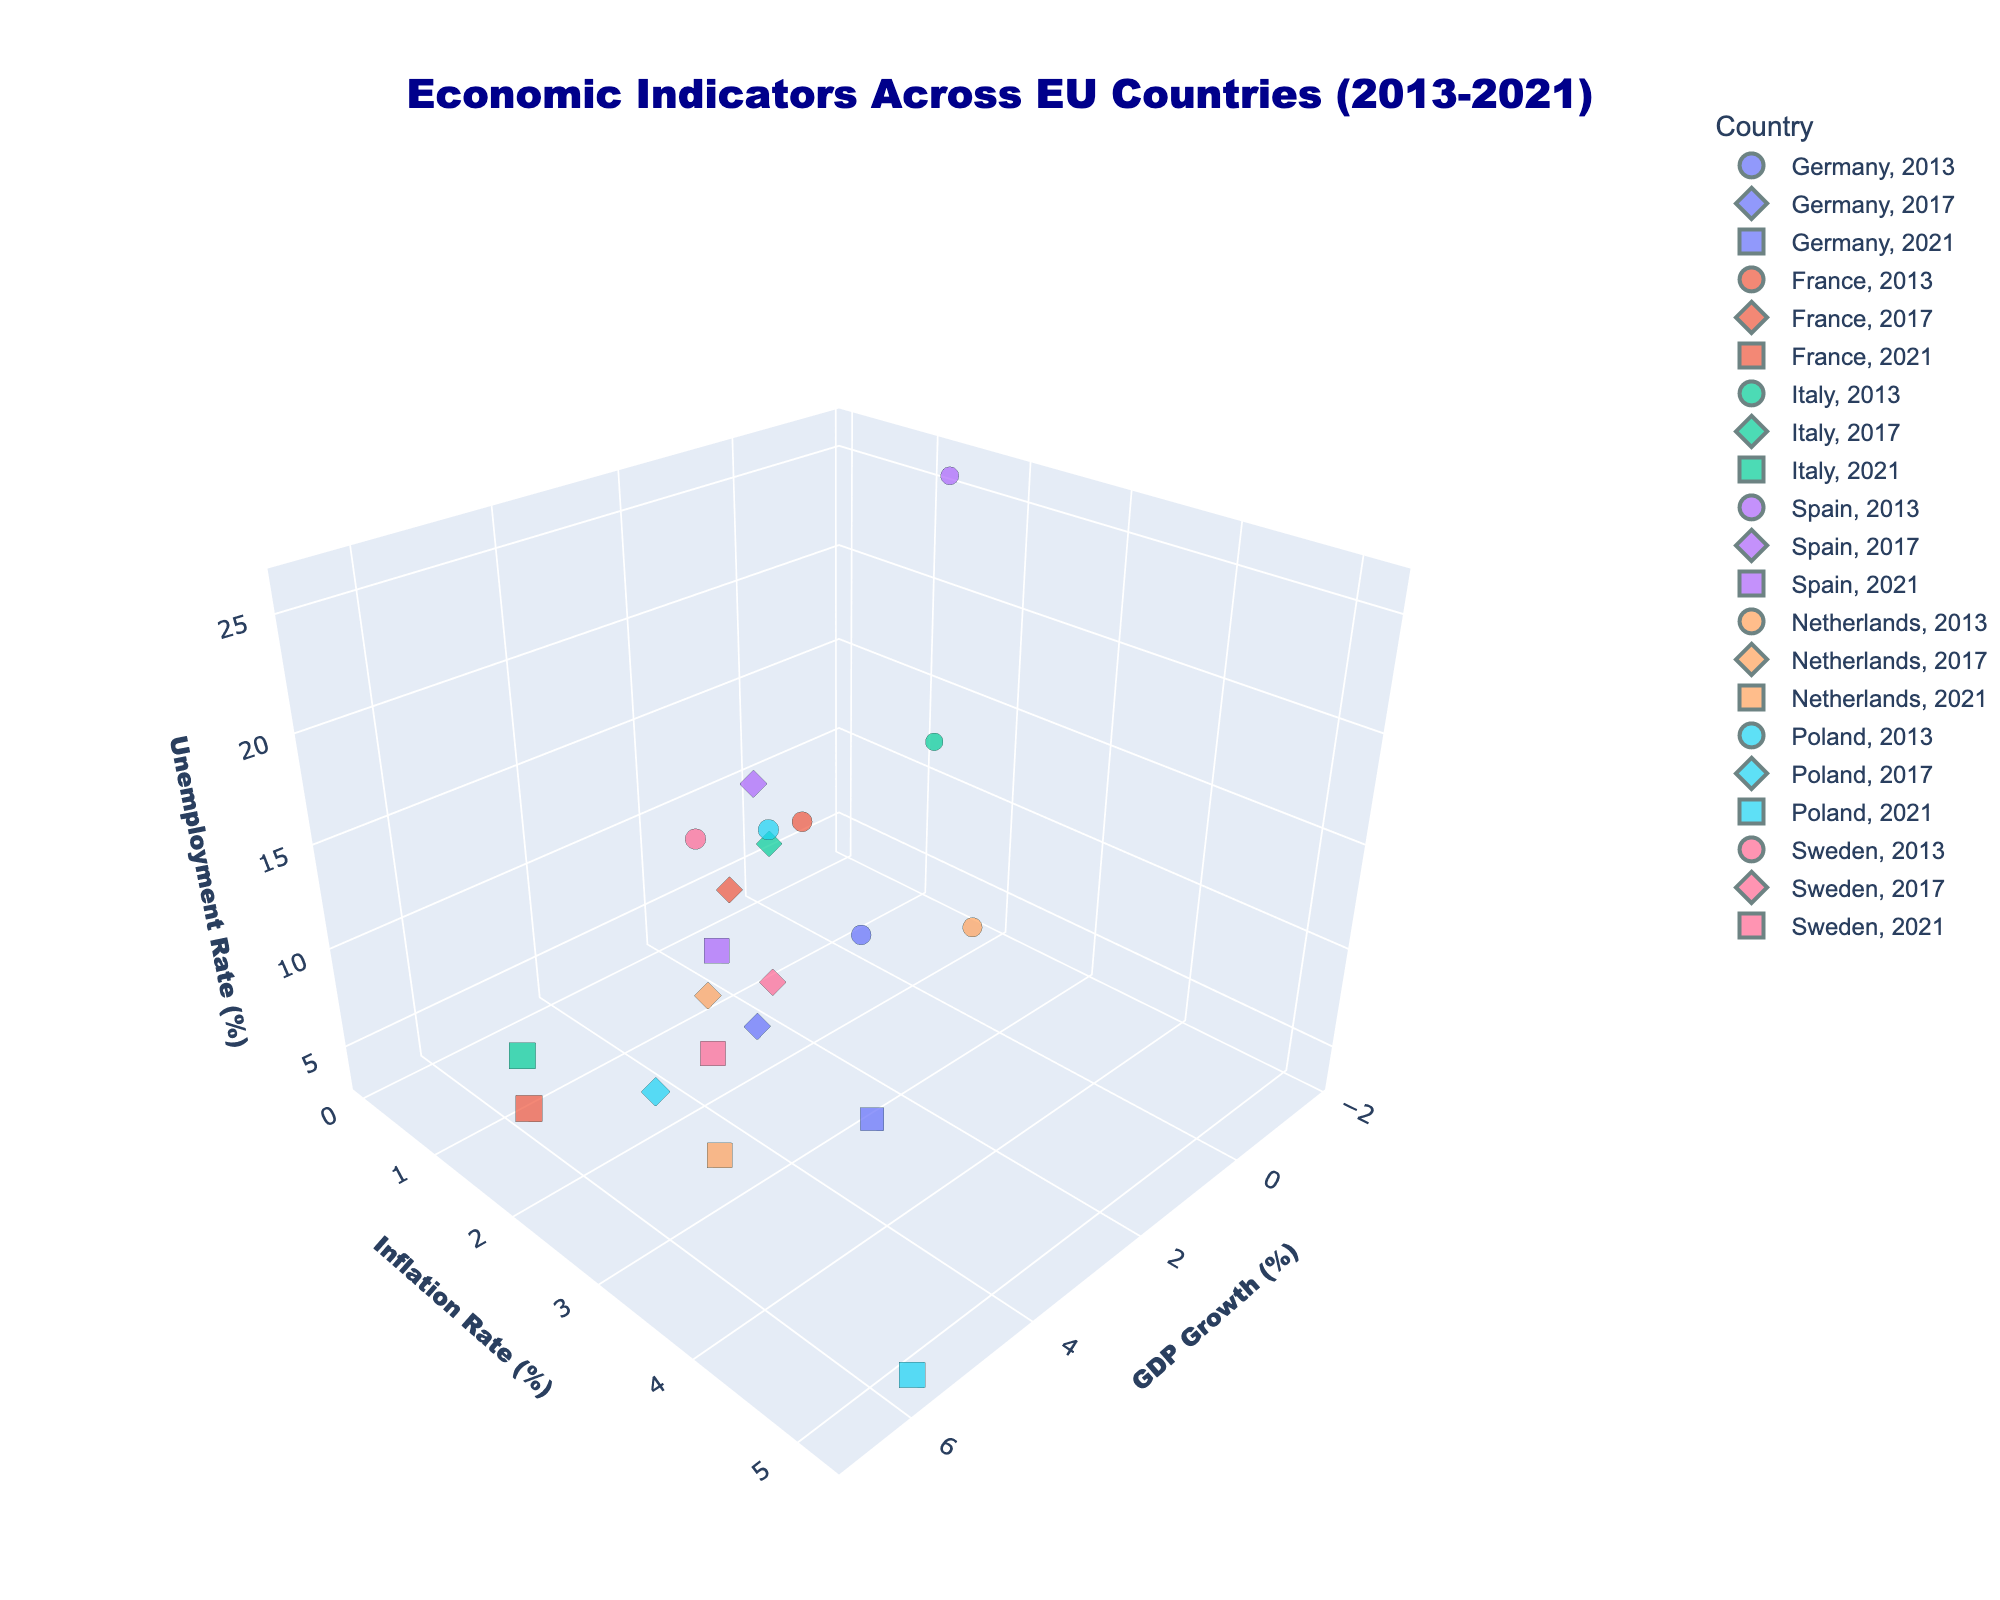What's the title of the figure? The title is usually located at the top and is the most prominent text in the figure. In this case, it is 'Economic Indicators Across EU Countries (2013-2021)'.
Answer: Economic Indicators Across EU Countries (2013-2021) Which country showed the highest GDP growth in 2021? To find this, look for the data points marked for 2021 across all countries and identify which one has the highest value on the GDP Growth axis.
Answer: France Was there any country with negative GDP growth in 2013? Scan the GDP Growth axis for data points corresponding to the year 2013 and see if any of them fall below zero.
Answer: Yes Which country had the highest unemployment rate in 2013? Look at the data points for 2013 and identify which one has the highest value on the Unemployment Rate axis.
Answer: Spain Compare the inflation rates of Germany and Poland in 2021. Which country had a higher rate? Locate the data points for Germany and Poland in 2021 and compare their values on the Inflation Rate axis.
Answer: Poland What is the trend of Sweden's unemployment rate from 2013 to 2021? Look at the data points for Sweden across the years 2013, 2017, and 2021, and see how the values change on the Unemployment Rate axis.
Answer: Increasing Between 2013 and 2017, which country's GDP growth improved the most? Calculate the difference in GDP growth between 2013 and 2017 for each country and identify which had the largest positive change.
Answer: Spain What is the average unemployment rate for Italy across the three years? Find the unemployment rates of Italy for 2013, 2017, and 2021. Sum these values and divide by 3 to get the average.
Answer: 10.93 Which country had a decrease in unemployment rate from 2017 to 2021? Compare the unemployment rates for each country between 2017 and 2021, and identify any countries with a lower value in 2021.
Answer: Spain Overall, which country had the most stable GDP growth rate over the years? Evaluate the GDP growth rates for each country in 2013, 2017, and 2021. The country with the least variation in these values is the most stable.
Answer: Germany 